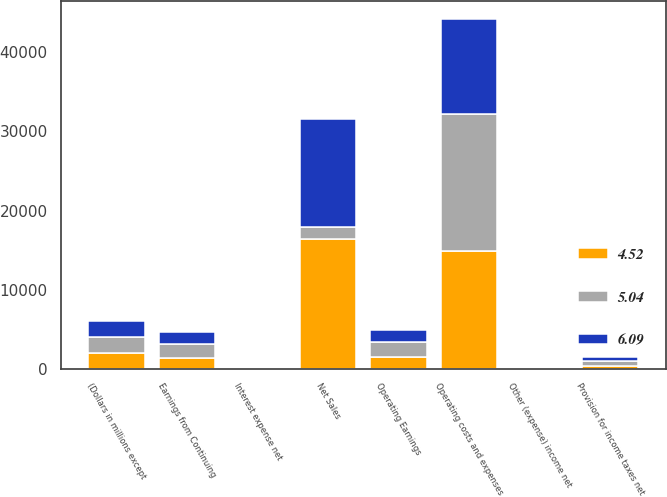Convert chart. <chart><loc_0><loc_0><loc_500><loc_500><stacked_bar_chart><ecel><fcel>(Dollars in millions except<fcel>Net Sales<fcel>Operating costs and expenses<fcel>Operating Earnings<fcel>Interest expense net<fcel>Other (expense) income net<fcel>Earnings from Continuing<fcel>Provision for income taxes net<nl><fcel>5.04<fcel>2004<fcel>1567<fcel>17237<fcel>1941<fcel>148<fcel>8<fcel>1785<fcel>582<nl><fcel>4.52<fcel>2003<fcel>16369<fcel>14924<fcel>1445<fcel>98<fcel>3<fcel>1350<fcel>368<nl><fcel>6.09<fcel>2002<fcel>13680<fcel>12113<fcel>1567<fcel>45<fcel>47<fcel>1569<fcel>529<nl></chart> 